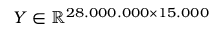<formula> <loc_0><loc_0><loc_500><loc_500>Y \in \mathbb { R } ^ { 2 8 . 0 0 0 . 0 0 0 \times 1 5 . 0 0 0 }</formula> 